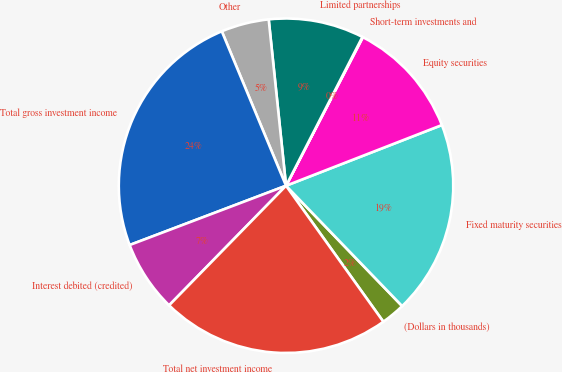Convert chart to OTSL. <chart><loc_0><loc_0><loc_500><loc_500><pie_chart><fcel>(Dollars in thousands)<fcel>Fixed maturity securities<fcel>Equity securities<fcel>Short-term investments and<fcel>Limited partnerships<fcel>Other<fcel>Total gross investment income<fcel>Interest debited (credited)<fcel>Total net investment income<nl><fcel>2.33%<fcel>18.69%<fcel>11.49%<fcel>0.05%<fcel>9.2%<fcel>4.62%<fcel>24.49%<fcel>6.91%<fcel>22.2%<nl></chart> 